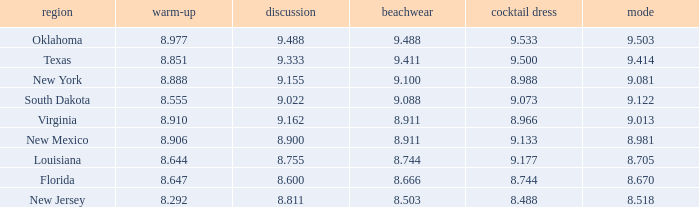 what's the swimsuit where average is 8.670 8.666. 